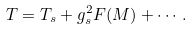<formula> <loc_0><loc_0><loc_500><loc_500>T = T _ { s } + g _ { s } ^ { 2 } F ( M ) + \cdots \, .</formula> 